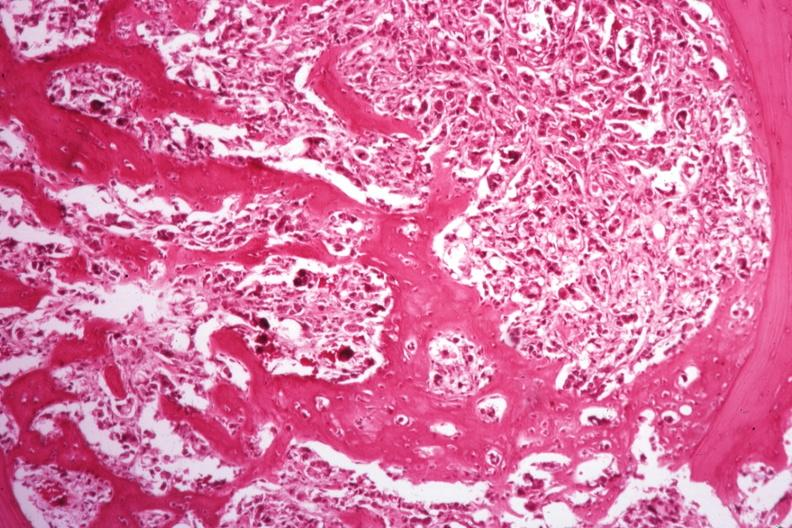what is present?
Answer the question using a single word or phrase. Joints 